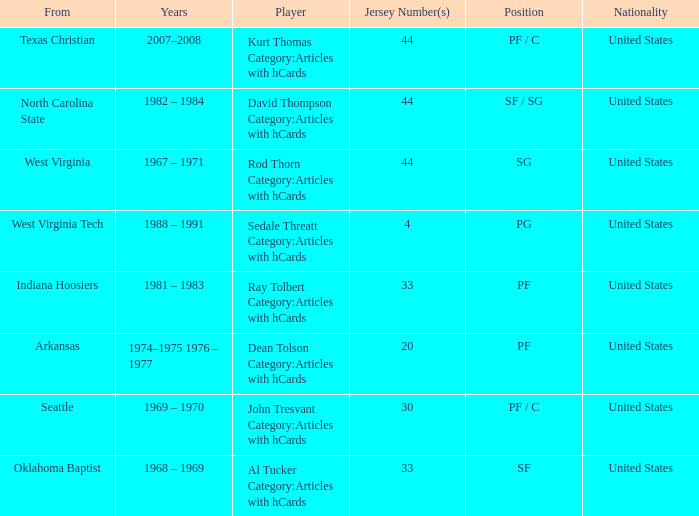Who was the player that was from west virginia tech? Sedale Threatt Category:Articles with hCards. 